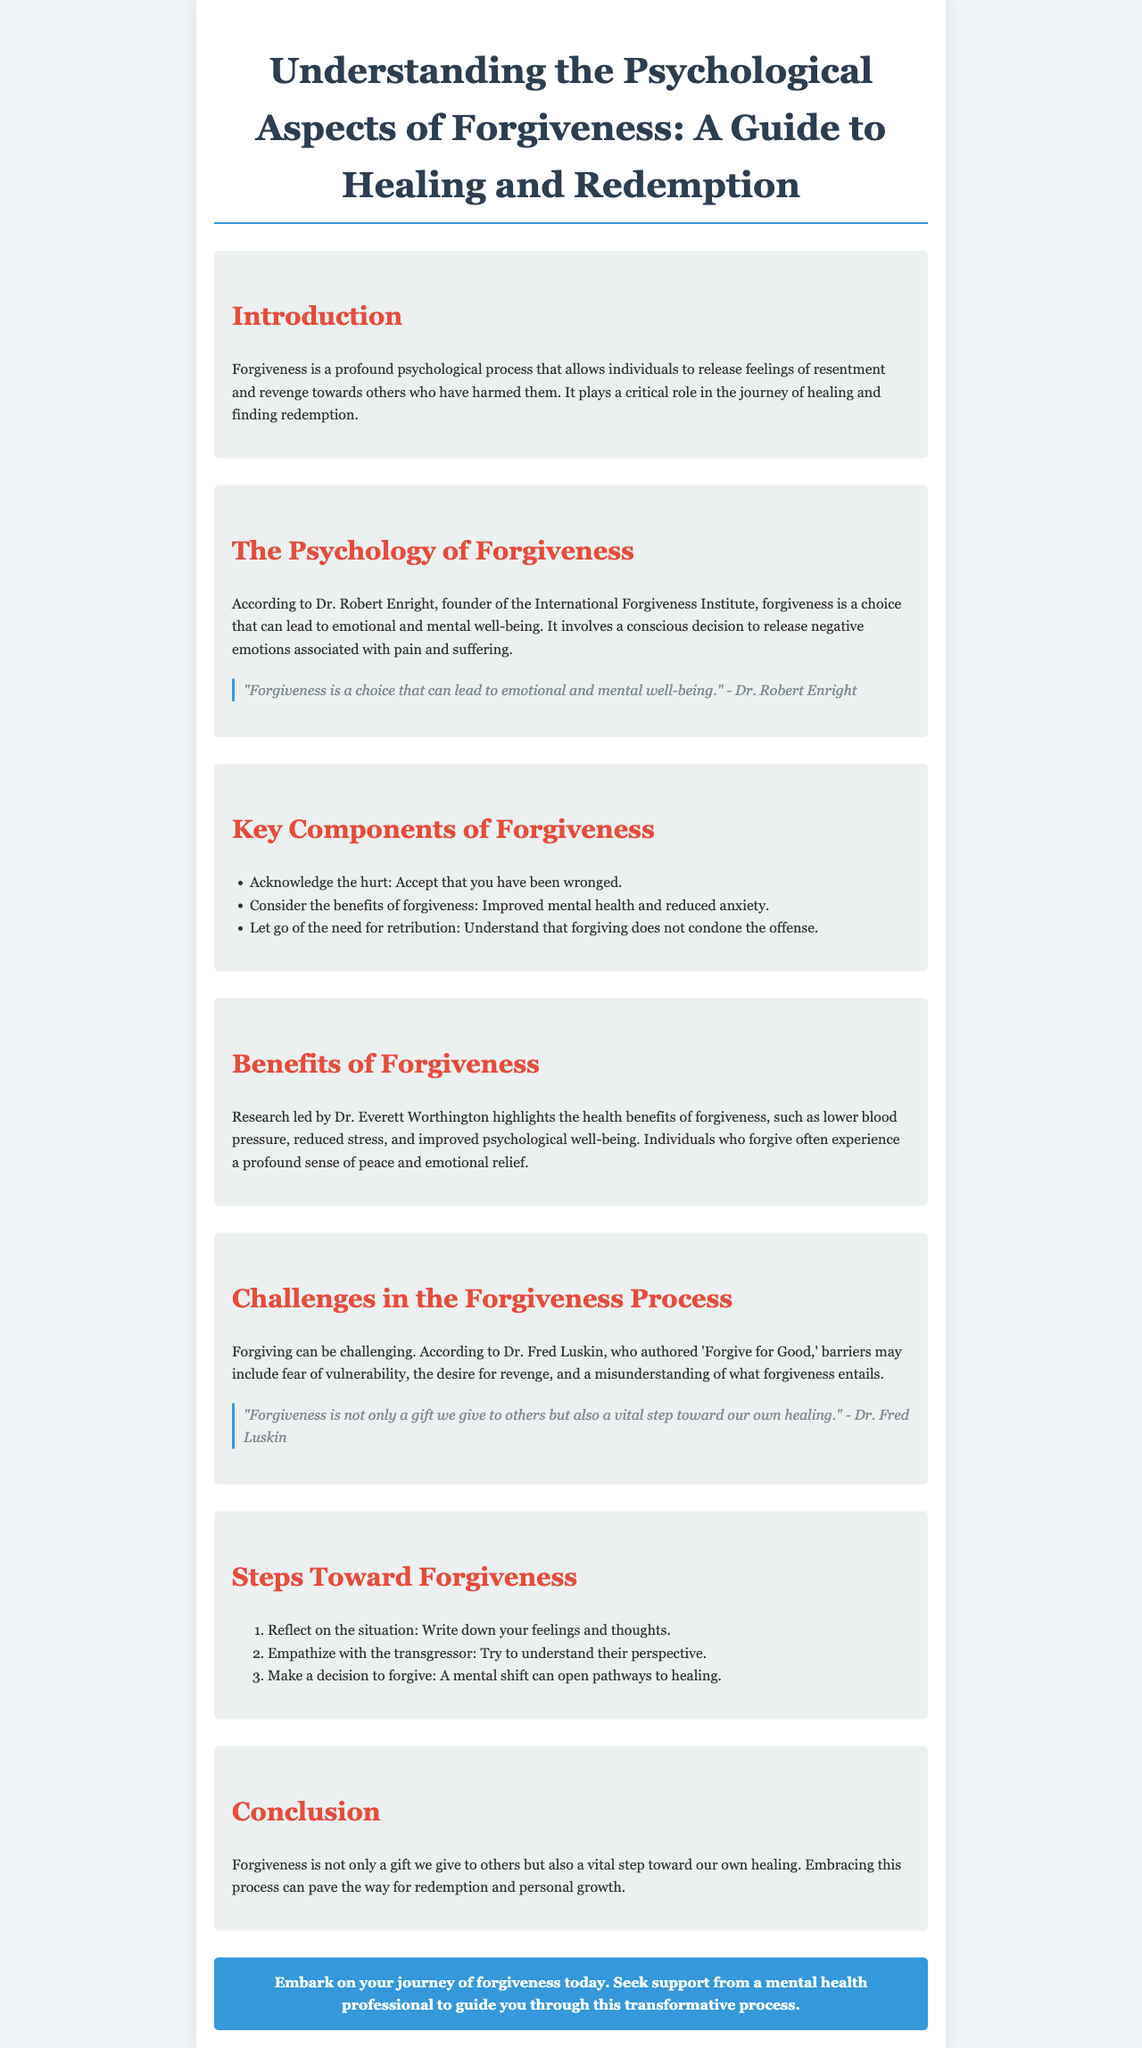what is the title of the brochure? The title is the main heading presented at the top of the document.
Answer: Understanding the Psychological Aspects of Forgiveness: A Guide to Healing and Redemption who is the founder of the International Forgiveness Institute? The founder is mentioned in the section "The Psychology of Forgiveness."
Answer: Dr. Robert Enright what are two health benefits of forgiveness mentioned in the brochure? The brochure lists benefits under the section "Benefits of Forgiveness."
Answer: Lower blood pressure, reduced stress what is one challenge in the forgiveness process? Challenges are discussed in the section "Challenges in the Forgiveness Process."
Answer: Fear of vulnerability how many steps are mentioned toward forgiveness? The number of steps is noted in the section "Steps Toward Forgiveness."
Answer: Three steps what is the purpose of forgiveness according to Dr. Fred Luskin? The purpose is noted in one of the quotes in the section "Challenges in the Forgiveness Process."
Answer: A vital step toward our own healing what is advised to seek for support in the process of forgiveness? The brochure mentions support options in the "call to action" section.
Answer: A mental health professional 